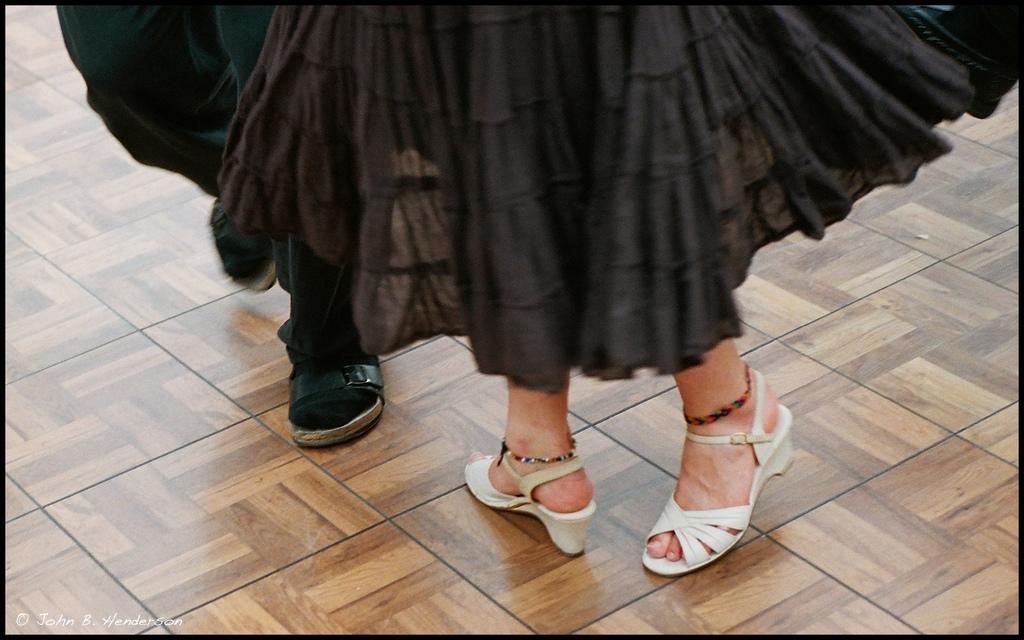In one or two sentences, can you explain what this image depicts? In the center of the image we can see legs of people. At the bottom there is floor. 